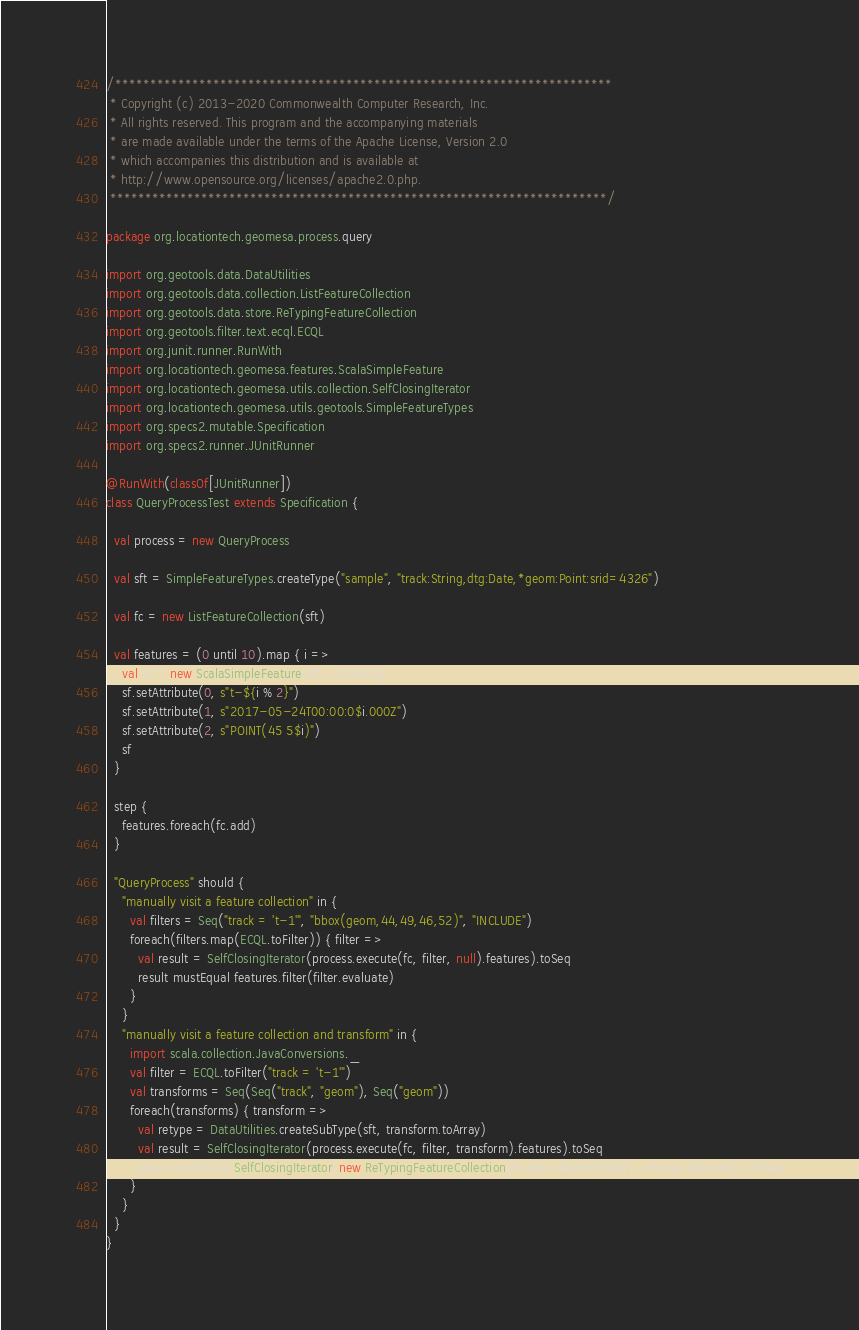Convert code to text. <code><loc_0><loc_0><loc_500><loc_500><_Scala_>/***********************************************************************
 * Copyright (c) 2013-2020 Commonwealth Computer Research, Inc.
 * All rights reserved. This program and the accompanying materials
 * are made available under the terms of the Apache License, Version 2.0
 * which accompanies this distribution and is available at
 * http://www.opensource.org/licenses/apache2.0.php.
 ***********************************************************************/

package org.locationtech.geomesa.process.query

import org.geotools.data.DataUtilities
import org.geotools.data.collection.ListFeatureCollection
import org.geotools.data.store.ReTypingFeatureCollection
import org.geotools.filter.text.ecql.ECQL
import org.junit.runner.RunWith
import org.locationtech.geomesa.features.ScalaSimpleFeature
import org.locationtech.geomesa.utils.collection.SelfClosingIterator
import org.locationtech.geomesa.utils.geotools.SimpleFeatureTypes
import org.specs2.mutable.Specification
import org.specs2.runner.JUnitRunner

@RunWith(classOf[JUnitRunner])
class QueryProcessTest extends Specification {

  val process = new QueryProcess

  val sft = SimpleFeatureTypes.createType("sample", "track:String,dtg:Date,*geom:Point:srid=4326")

  val fc = new ListFeatureCollection(sft)

  val features = (0 until 10).map { i =>
    val sf = new ScalaSimpleFeature(sft, i.toString)
    sf.setAttribute(0, s"t-${i % 2}")
    sf.setAttribute(1, s"2017-05-24T00:00:0$i.000Z")
    sf.setAttribute(2, s"POINT(45 5$i)")
    sf
  }

  step {
    features.foreach(fc.add)
  }

  "QueryProcess" should {
    "manually visit a feature collection" in {
      val filters = Seq("track = 't-1'", "bbox(geom,44,49,46,52)", "INCLUDE")
      foreach(filters.map(ECQL.toFilter)) { filter =>
        val result = SelfClosingIterator(process.execute(fc, filter, null).features).toSeq
        result mustEqual features.filter(filter.evaluate)
      }
    }
    "manually visit a feature collection and transform" in {
      import scala.collection.JavaConversions._
      val filter = ECQL.toFilter("track = 't-1'")
      val transforms = Seq(Seq("track", "geom"), Seq("geom"))
      foreach(transforms) { transform =>
        val retype = DataUtilities.createSubType(sft, transform.toArray)
        val result = SelfClosingIterator(process.execute(fc, filter, transform).features).toSeq
        result mustEqual SelfClosingIterator(new ReTypingFeatureCollection(fc.subCollection(filter), retype).features()).toSeq
      }
    }
  }
}
</code> 